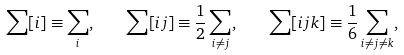Convert formula to latex. <formula><loc_0><loc_0><loc_500><loc_500>\sum [ i ] \equiv \sum _ { i } , \quad \sum [ i j ] \equiv \frac { 1 } { 2 } \sum _ { i \not = j } , \quad \sum [ i j k ] \equiv \frac { 1 } { 6 } \sum _ { i \not = j \not = k } ,</formula> 